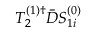Convert formula to latex. <formula><loc_0><loc_0><loc_500><loc_500>T _ { 2 } ^ { ( 1 ) \dagger } \bar { D } S _ { 1 i } ^ { ( 0 ) }</formula> 